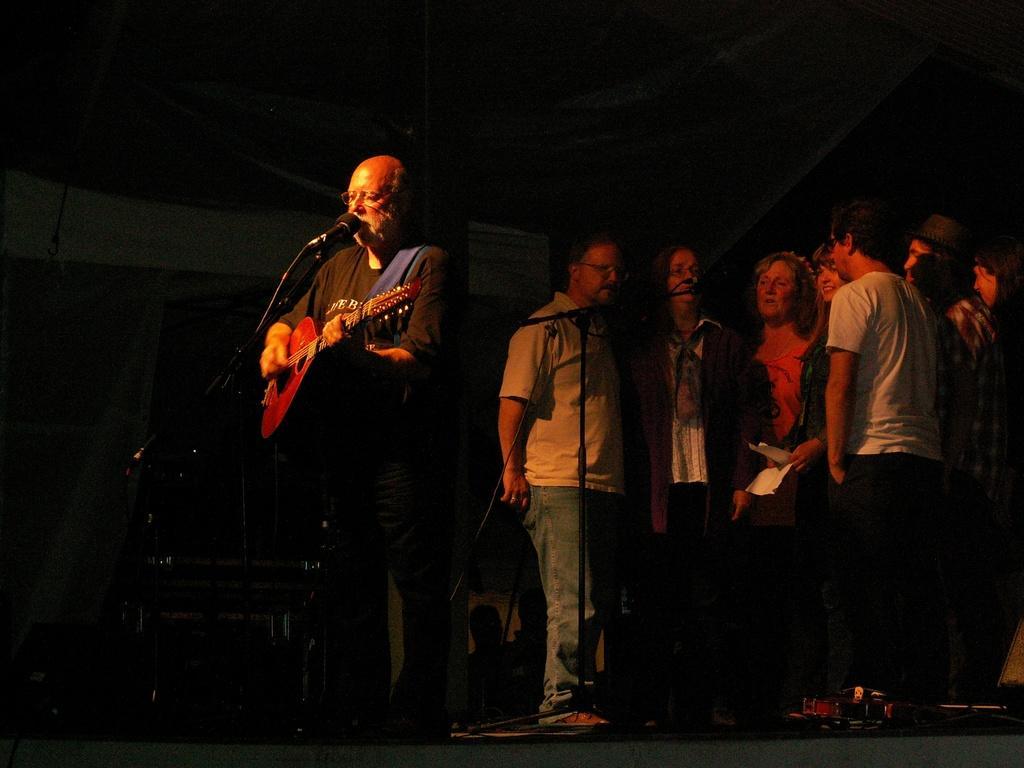How would you summarize this image in a sentence or two? In the image there are group of people who are standing and playing their musical instrument. In middle there is a man holding his musical instrument and singing in front of a microphone. In background there are group of people who are singing in front of a microphone. 